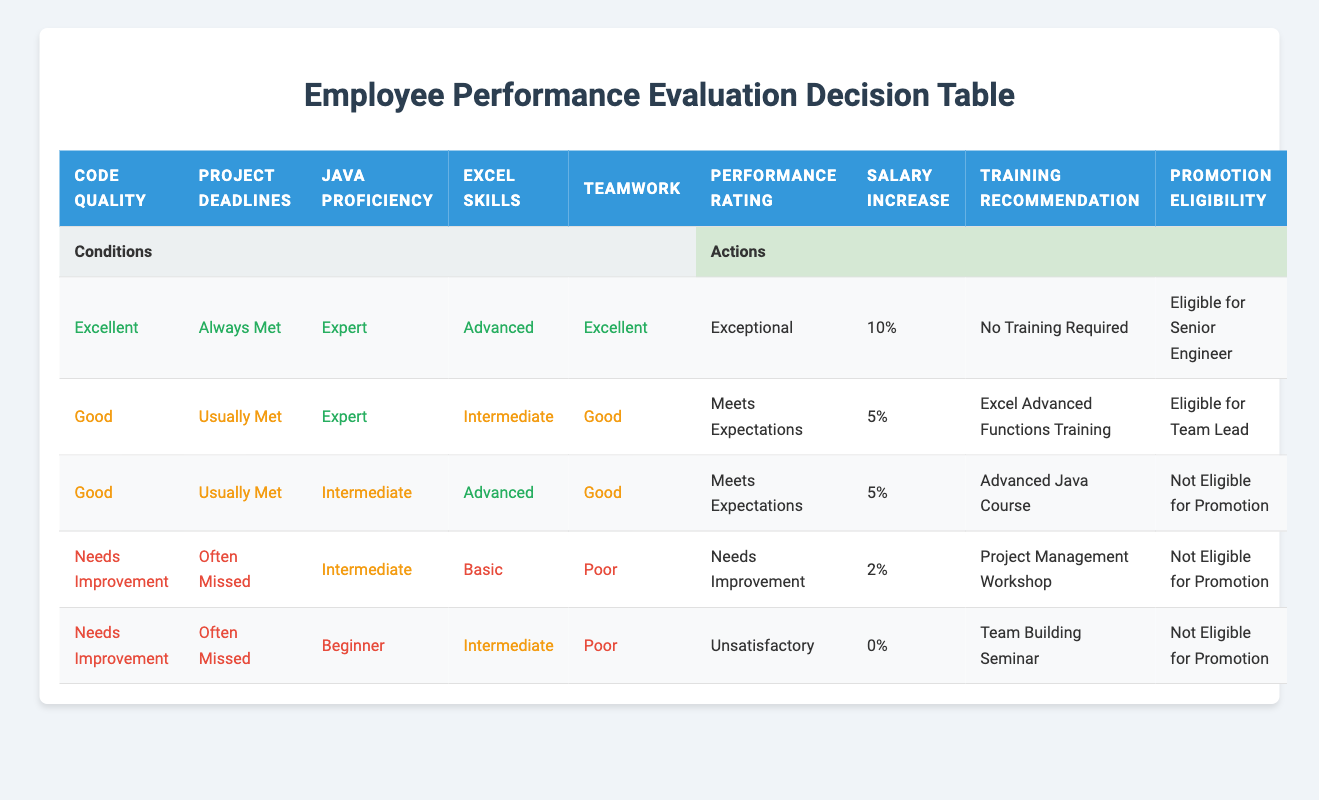What is the performance rating for someone who has excellent code quality, always meets deadlines, is proficient in Java at an expert level, has advanced Excel skills, and demonstrates excellent teamwork? According to the first row of the table, these specific conditions lead to a performance rating of "Exceptional."
Answer: Exceptional What salary increase is given to an employee who has good code quality, usually meets deadlines, is an expert in Java, has intermediate Excel skills, and shows good teamwork? From the second row of the table, this combination of attributes results in a salary increase of "5%."
Answer: 5% Is a person who has intermediate Java proficiency and meets project deadlines often considered eligible for a promotion? Looking at the last two rules, both sets of conditions (needs improvement with often missed deadlines leads to "Not Eligible for Promotion") confirm that this condition results in "Not Eligible for Promotion."
Answer: No What training is recommended for someone who needs improvement in code quality, often misses project deadlines, and has basic Excel skills? Referring to the fourth and fifth rows of the table, those conditions suggest a recommendation for "Project Management Workshop" in the fourth case and "Team Building Seminar" in the fifth, thus confirming training is required.
Answer: Project Management Workshop What is the total percentage salary increase for all employees rated as "Meets Expectations"? The rows corresponding to "Meets Expectations" are the second and third rows, which provide a 5% increase each. Therefore, the total is 5% + 5% = 10%.
Answer: 10% 